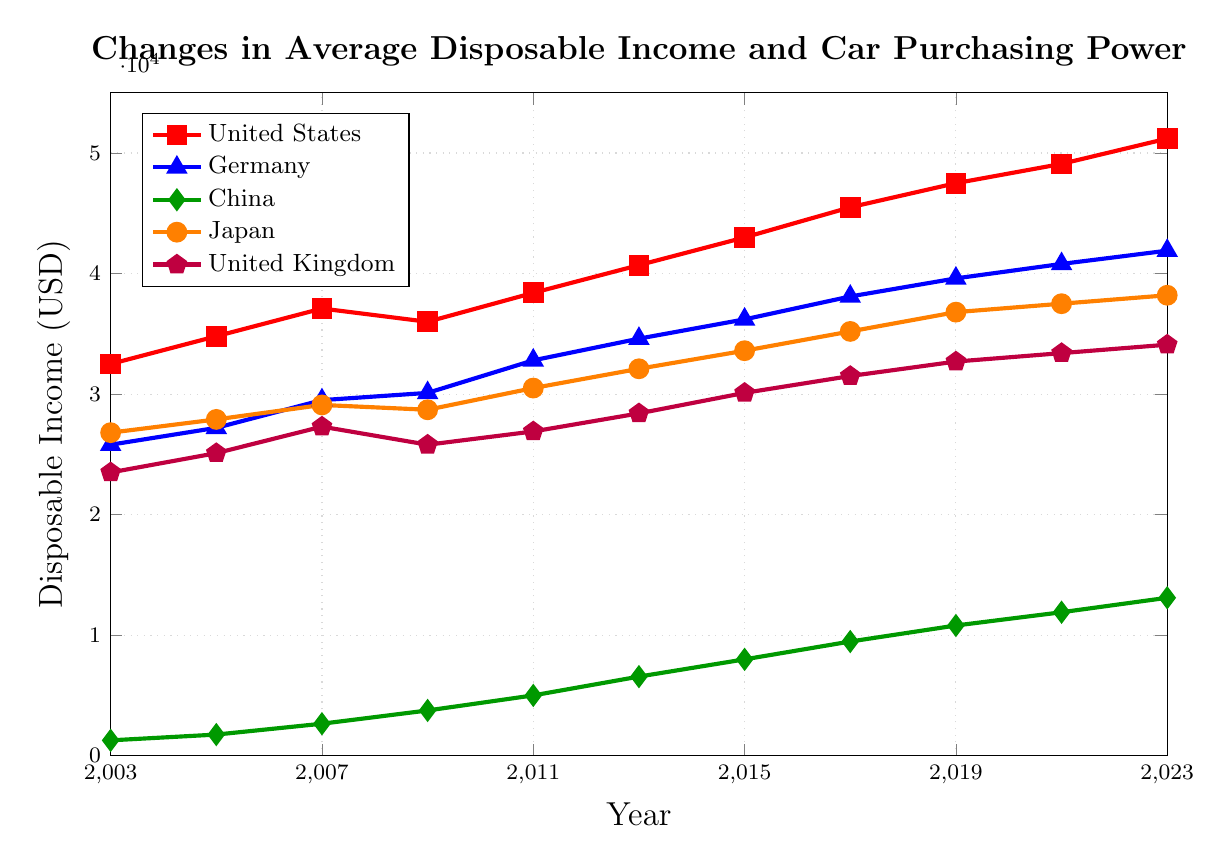what is the overall trend in disposable income for the United States from 2003 to 2023? By observing the red line representing the United States, we can see a consistent increase in disposable income from 32,500 USD in 2003 to 51,200 USD in 2023. This suggests a steady upward trend.
Answer: Increasing Which country had the highest disposable income in 2023? From the plot, the red line (United States) is positioned the highest at 51,200 USD in 2023, indicating that the US had the highest disposable income.
Answer: United States By how much did China's disposable income increase between 2003 and 2023? In 2003, China's income was 1,270 USD, and in 2023 it was 13,100 USD. The increase is 13,100 - 1,270 = 11,830 USD.
Answer: 11,830 USD In which year did Germany's disposable income first exceed 30,000 USD? The blue line representing Germany first crosses the 30,000 USD mark in 2009, showing an income of 30,100 USD.
Answer: 2009 How does the disposable income trend of the United Kingdom compare to Japan from 2003 to 2023? By comparing the purple and orange lines, we observe that the disposable incomes of both countries follow a similar upward pattern, with Japan consistently having a higher disposable income than the United Kingdom throughout the period.
Answer: Japan consistently higher; both increase What was the disposable income for Japan in 2011, and how does it compare with the United States in the same year? In 2011, Japan's disposable income was 30,500 USD, while the US had 38,400 USD. Comparatively, the US had 7,900 USD more than Japan in that year.
Answer: Japan: 30,500 USD, US: +7,900 USD Which country showed the most rapid increase in disposable income and over what period? The green line for China shows the most rapid increase, rising from 1,270 USD in 2003 to 13,100 USD in 2023, indicating a significant growth rate.
Answer: China (2003-2023) What is the approximate average annual increase in disposable income for the United States from 2003 to 2023? The total increase for the United States from 2003 (32,500 USD) to 2023 (51,200 USD) is 18,700 USD over 20 years. The average annual increase is 18,700 / 20 = 935 USD per year.
Answer: 935 USD per year Which country's disposable income was nearly the same in 2009 and 2011? Observing the plot, Japan had a disposable income of 28,700 USD in 2009 and 30,500 USD in 2011, showing only a slight increase, relatively stable compared to other countries.
Answer: Japan 